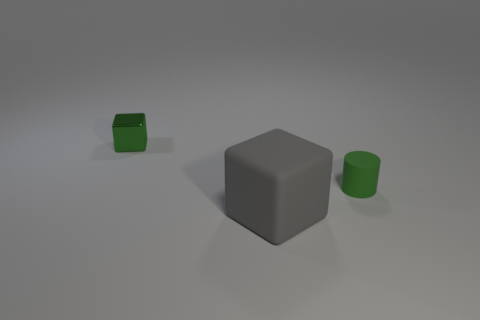Add 2 big green balls. How many objects exist? 5 Subtract all cubes. How many objects are left? 1 Add 2 tiny green cylinders. How many tiny green cylinders are left? 3 Add 1 large green things. How many large green things exist? 1 Subtract 0 cyan blocks. How many objects are left? 3 Subtract all green shiny cubes. Subtract all tiny yellow cubes. How many objects are left? 2 